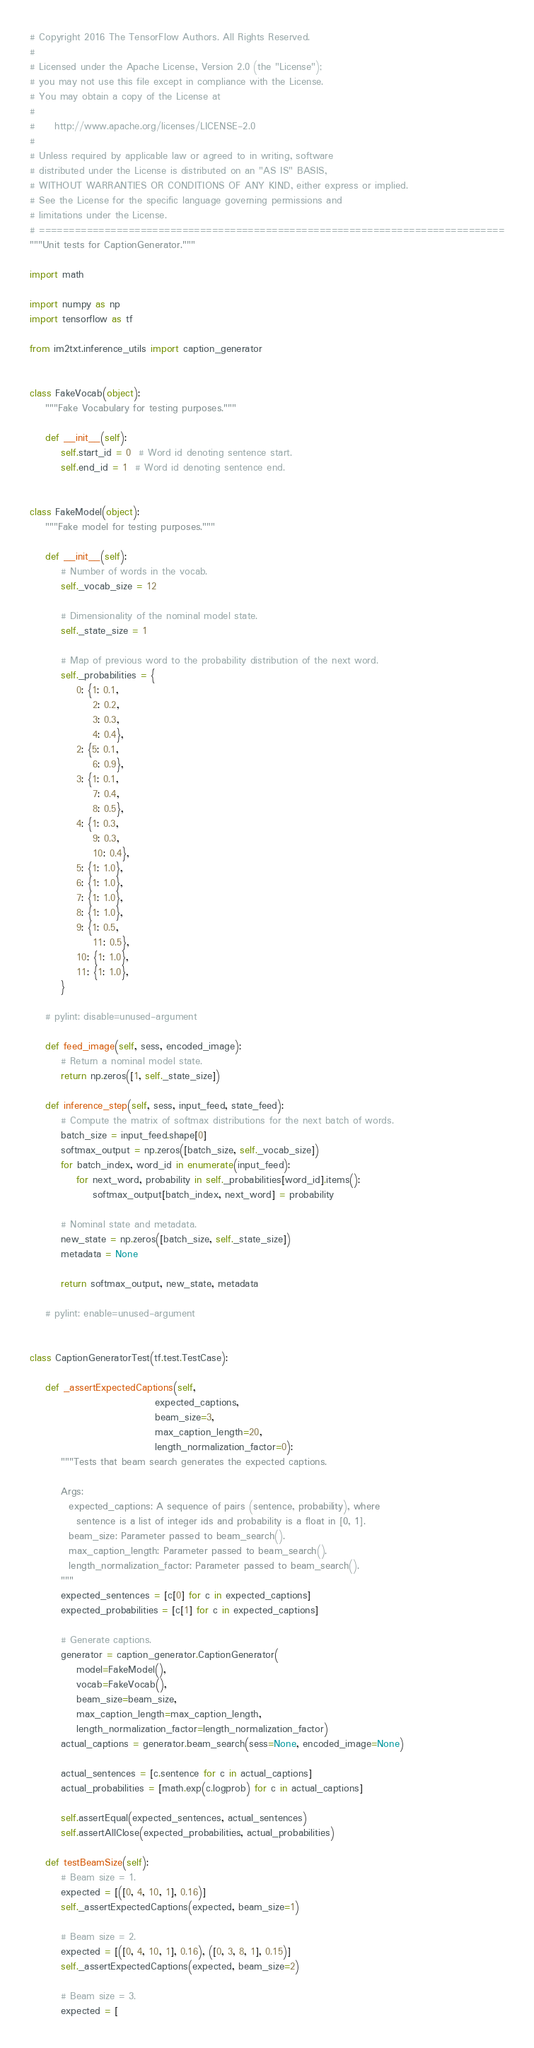Convert code to text. <code><loc_0><loc_0><loc_500><loc_500><_Python_># Copyright 2016 The TensorFlow Authors. All Rights Reserved.
#
# Licensed under the Apache License, Version 2.0 (the "License");
# you may not use this file except in compliance with the License.
# You may obtain a copy of the License at
#
#     http://www.apache.org/licenses/LICENSE-2.0
#
# Unless required by applicable law or agreed to in writing, software
# distributed under the License is distributed on an "AS IS" BASIS,
# WITHOUT WARRANTIES OR CONDITIONS OF ANY KIND, either express or implied.
# See the License for the specific language governing permissions and
# limitations under the License.
# ==============================================================================
"""Unit tests for CaptionGenerator."""

import math

import numpy as np
import tensorflow as tf

from im2txt.inference_utils import caption_generator


class FakeVocab(object):
    """Fake Vocabulary for testing purposes."""

    def __init__(self):
        self.start_id = 0  # Word id denoting sentence start.
        self.end_id = 1  # Word id denoting sentence end.


class FakeModel(object):
    """Fake model for testing purposes."""

    def __init__(self):
        # Number of words in the vocab.
        self._vocab_size = 12

        # Dimensionality of the nominal model state.
        self._state_size = 1

        # Map of previous word to the probability distribution of the next word.
        self._probabilities = {
            0: {1: 0.1,
                2: 0.2,
                3: 0.3,
                4: 0.4},
            2: {5: 0.1,
                6: 0.9},
            3: {1: 0.1,
                7: 0.4,
                8: 0.5},
            4: {1: 0.3,
                9: 0.3,
                10: 0.4},
            5: {1: 1.0},
            6: {1: 1.0},
            7: {1: 1.0},
            8: {1: 1.0},
            9: {1: 0.5,
                11: 0.5},
            10: {1: 1.0},
            11: {1: 1.0},
        }

    # pylint: disable=unused-argument

    def feed_image(self, sess, encoded_image):
        # Return a nominal model state.
        return np.zeros([1, self._state_size])

    def inference_step(self, sess, input_feed, state_feed):
        # Compute the matrix of softmax distributions for the next batch of words.
        batch_size = input_feed.shape[0]
        softmax_output = np.zeros([batch_size, self._vocab_size])
        for batch_index, word_id in enumerate(input_feed):
            for next_word, probability in self._probabilities[word_id].items():
                softmax_output[batch_index, next_word] = probability

        # Nominal state and metadata.
        new_state = np.zeros([batch_size, self._state_size])
        metadata = None

        return softmax_output, new_state, metadata

    # pylint: enable=unused-argument


class CaptionGeneratorTest(tf.test.TestCase):

    def _assertExpectedCaptions(self,
                                expected_captions,
                                beam_size=3,
                                max_caption_length=20,
                                length_normalization_factor=0):
        """Tests that beam search generates the expected captions.
    
        Args:
          expected_captions: A sequence of pairs (sentence, probability), where
            sentence is a list of integer ids and probability is a float in [0, 1].
          beam_size: Parameter passed to beam_search().
          max_caption_length: Parameter passed to beam_search().
          length_normalization_factor: Parameter passed to beam_search().
        """
        expected_sentences = [c[0] for c in expected_captions]
        expected_probabilities = [c[1] for c in expected_captions]

        # Generate captions.
        generator = caption_generator.CaptionGenerator(
            model=FakeModel(),
            vocab=FakeVocab(),
            beam_size=beam_size,
            max_caption_length=max_caption_length,
            length_normalization_factor=length_normalization_factor)
        actual_captions = generator.beam_search(sess=None, encoded_image=None)

        actual_sentences = [c.sentence for c in actual_captions]
        actual_probabilities = [math.exp(c.logprob) for c in actual_captions]

        self.assertEqual(expected_sentences, actual_sentences)
        self.assertAllClose(expected_probabilities, actual_probabilities)

    def testBeamSize(self):
        # Beam size = 1.
        expected = [([0, 4, 10, 1], 0.16)]
        self._assertExpectedCaptions(expected, beam_size=1)

        # Beam size = 2.
        expected = [([0, 4, 10, 1], 0.16), ([0, 3, 8, 1], 0.15)]
        self._assertExpectedCaptions(expected, beam_size=2)

        # Beam size = 3.
        expected = [</code> 